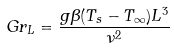Convert formula to latex. <formula><loc_0><loc_0><loc_500><loc_500>G r _ { L } = { \frac { g \beta ( T _ { s } - T _ { \infty } ) L ^ { 3 } } { \nu ^ { 2 } } }</formula> 